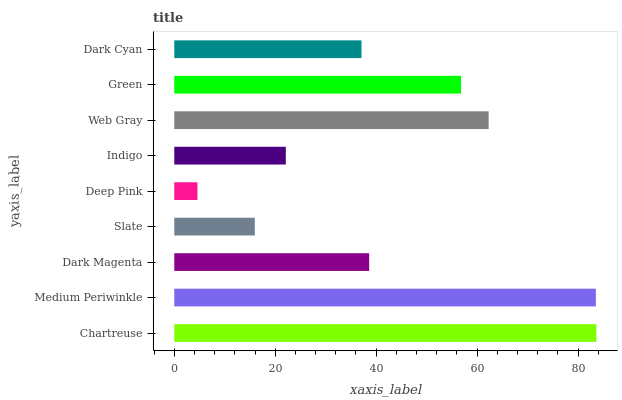Is Deep Pink the minimum?
Answer yes or no. Yes. Is Chartreuse the maximum?
Answer yes or no. Yes. Is Medium Periwinkle the minimum?
Answer yes or no. No. Is Medium Periwinkle the maximum?
Answer yes or no. No. Is Chartreuse greater than Medium Periwinkle?
Answer yes or no. Yes. Is Medium Periwinkle less than Chartreuse?
Answer yes or no. Yes. Is Medium Periwinkle greater than Chartreuse?
Answer yes or no. No. Is Chartreuse less than Medium Periwinkle?
Answer yes or no. No. Is Dark Magenta the high median?
Answer yes or no. Yes. Is Dark Magenta the low median?
Answer yes or no. Yes. Is Medium Periwinkle the high median?
Answer yes or no. No. Is Slate the low median?
Answer yes or no. No. 